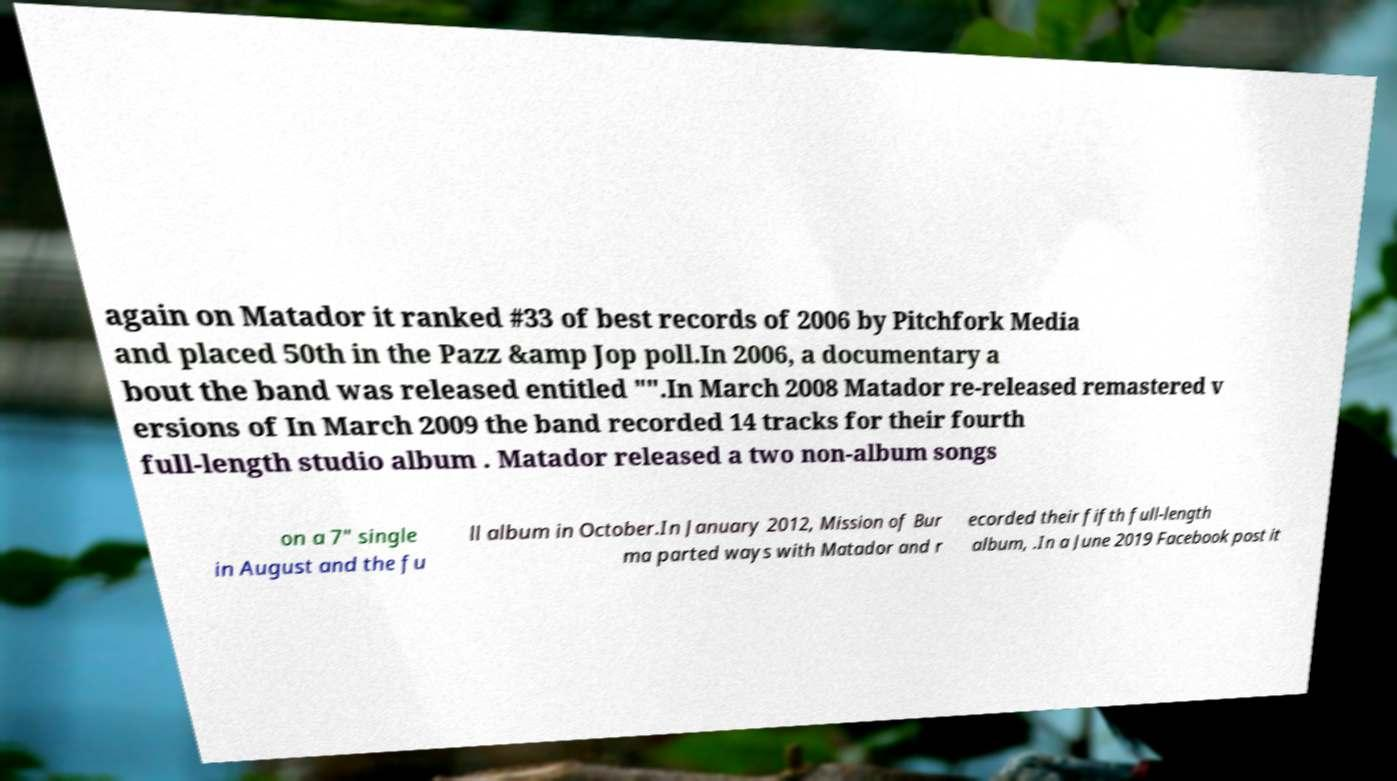I need the written content from this picture converted into text. Can you do that? again on Matador it ranked #33 of best records of 2006 by Pitchfork Media and placed 50th in the Pazz &amp Jop poll.In 2006, a documentary a bout the band was released entitled "".In March 2008 Matador re-released remastered v ersions of In March 2009 the band recorded 14 tracks for their fourth full-length studio album . Matador released a two non-album songs on a 7″ single in August and the fu ll album in October.In January 2012, Mission of Bur ma parted ways with Matador and r ecorded their fifth full-length album, .In a June 2019 Facebook post it 